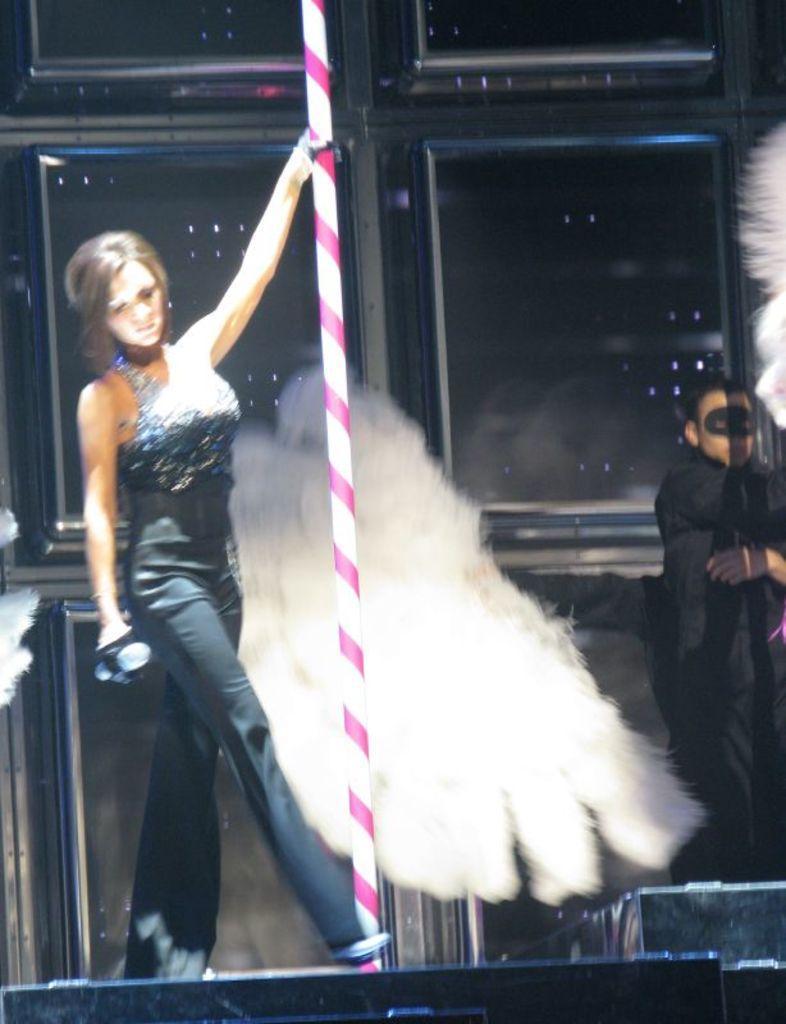Please provide a concise description of this image. In this image, we can see a woman standing and she is holding a pipe, on the right side we can see a person standing. 